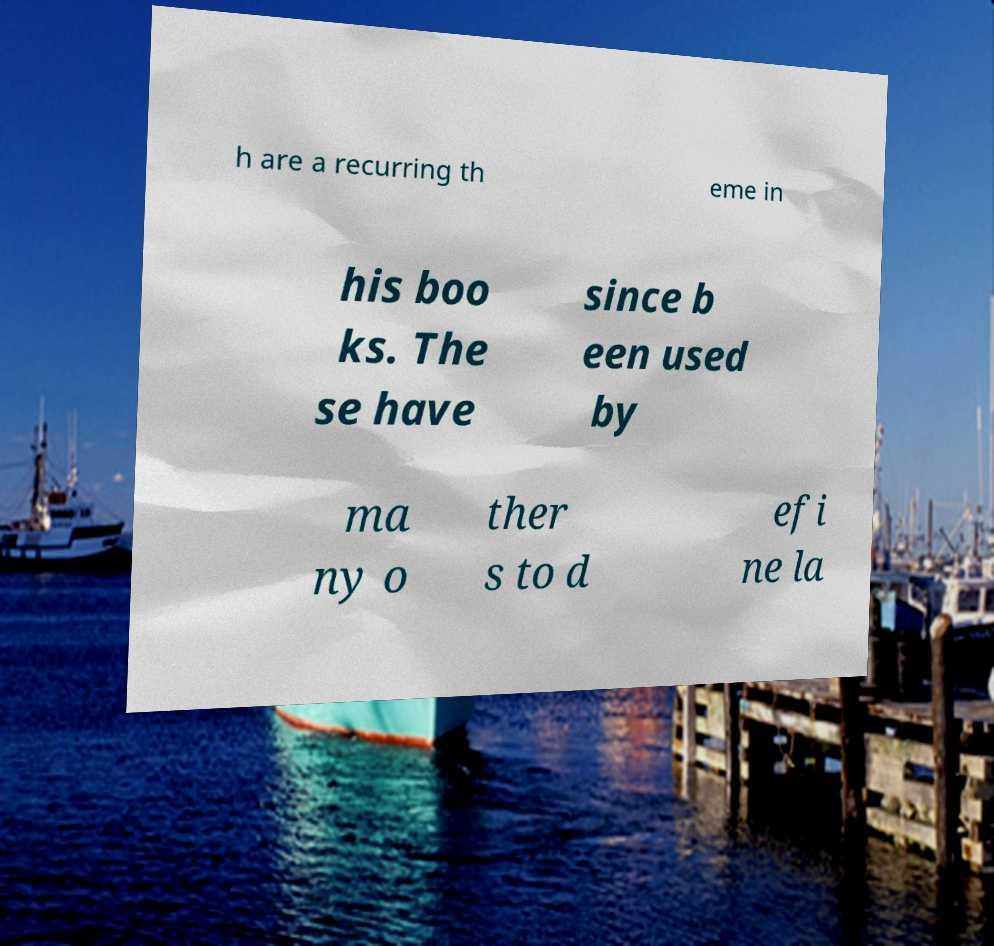Please read and relay the text visible in this image. What does it say? h are a recurring th eme in his boo ks. The se have since b een used by ma ny o ther s to d efi ne la 